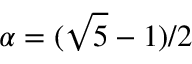<formula> <loc_0><loc_0><loc_500><loc_500>\alpha = ( \sqrt { 5 } - 1 ) / 2</formula> 